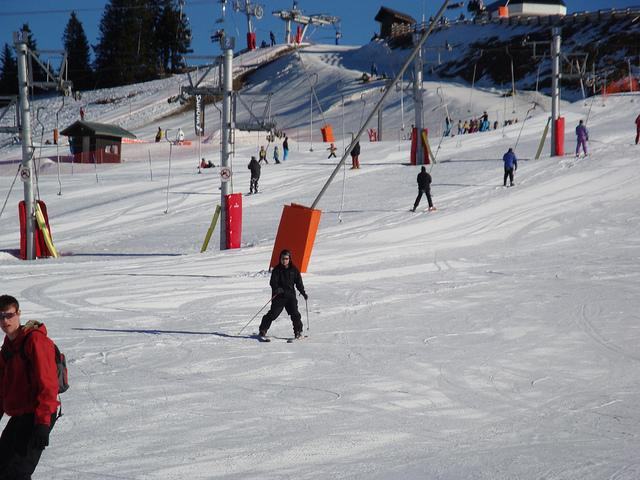What is the man dressed in all black and in the middle of the scene holding? ski poles 